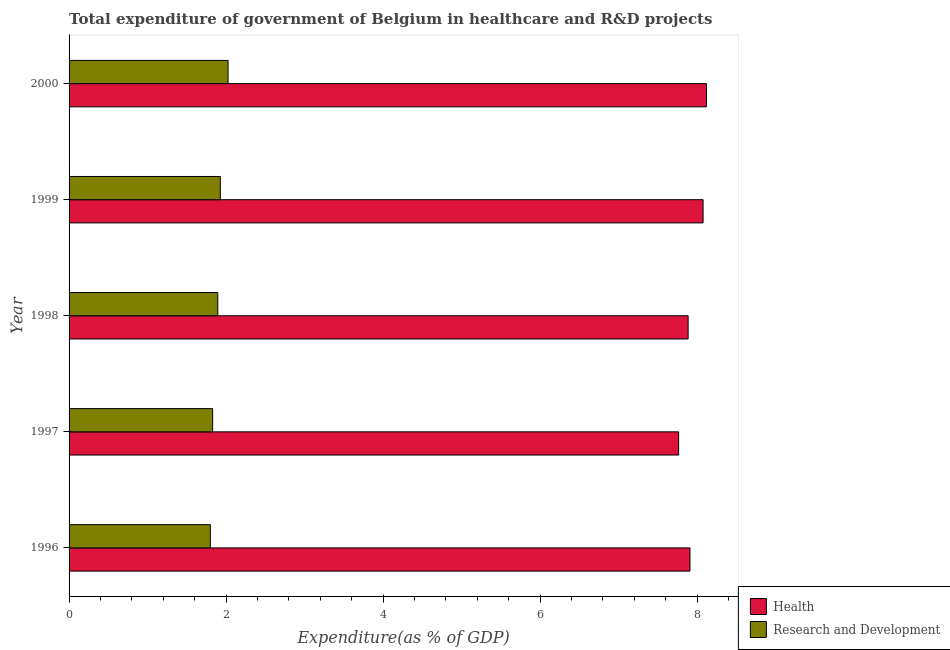How many groups of bars are there?
Provide a short and direct response. 5. Are the number of bars per tick equal to the number of legend labels?
Make the answer very short. Yes. How many bars are there on the 1st tick from the top?
Give a very brief answer. 2. How many bars are there on the 5th tick from the bottom?
Your answer should be compact. 2. In how many cases, is the number of bars for a given year not equal to the number of legend labels?
Ensure brevity in your answer.  0. What is the expenditure in r&d in 2000?
Provide a short and direct response. 2.03. Across all years, what is the maximum expenditure in healthcare?
Offer a terse response. 8.12. Across all years, what is the minimum expenditure in r&d?
Offer a terse response. 1.8. In which year was the expenditure in healthcare maximum?
Keep it short and to the point. 2000. What is the total expenditure in healthcare in the graph?
Your answer should be very brief. 39.76. What is the difference between the expenditure in healthcare in 1997 and that in 2000?
Provide a short and direct response. -0.35. What is the difference between the expenditure in healthcare in 2000 and the expenditure in r&d in 1997?
Provide a succinct answer. 6.29. What is the average expenditure in healthcare per year?
Make the answer very short. 7.95. In the year 1998, what is the difference between the expenditure in r&d and expenditure in healthcare?
Keep it short and to the point. -5.99. In how many years, is the expenditure in r&d greater than 4 %?
Ensure brevity in your answer.  0. What is the ratio of the expenditure in r&d in 1999 to that in 2000?
Provide a short and direct response. 0.95. Is the expenditure in healthcare in 1997 less than that in 2000?
Offer a very short reply. Yes. What is the difference between the highest and the second highest expenditure in r&d?
Offer a terse response. 0.1. What is the difference between the highest and the lowest expenditure in r&d?
Give a very brief answer. 0.23. In how many years, is the expenditure in healthcare greater than the average expenditure in healthcare taken over all years?
Provide a succinct answer. 2. Is the sum of the expenditure in healthcare in 1998 and 2000 greater than the maximum expenditure in r&d across all years?
Offer a terse response. Yes. What does the 2nd bar from the top in 1996 represents?
Your answer should be compact. Health. What does the 2nd bar from the bottom in 1998 represents?
Offer a very short reply. Research and Development. How many years are there in the graph?
Provide a short and direct response. 5. Are the values on the major ticks of X-axis written in scientific E-notation?
Offer a terse response. No. Does the graph contain any zero values?
Give a very brief answer. No. Where does the legend appear in the graph?
Provide a short and direct response. Bottom right. What is the title of the graph?
Provide a succinct answer. Total expenditure of government of Belgium in healthcare and R&D projects. Does "National Tourists" appear as one of the legend labels in the graph?
Your response must be concise. No. What is the label or title of the X-axis?
Your answer should be compact. Expenditure(as % of GDP). What is the label or title of the Y-axis?
Ensure brevity in your answer.  Year. What is the Expenditure(as % of GDP) of Health in 1996?
Offer a terse response. 7.91. What is the Expenditure(as % of GDP) in Research and Development in 1996?
Your response must be concise. 1.8. What is the Expenditure(as % of GDP) of Health in 1997?
Offer a very short reply. 7.77. What is the Expenditure(as % of GDP) of Research and Development in 1997?
Offer a very short reply. 1.83. What is the Expenditure(as % of GDP) in Health in 1998?
Offer a very short reply. 7.89. What is the Expenditure(as % of GDP) in Research and Development in 1998?
Offer a terse response. 1.89. What is the Expenditure(as % of GDP) in Health in 1999?
Offer a terse response. 8.08. What is the Expenditure(as % of GDP) of Research and Development in 1999?
Provide a succinct answer. 1.93. What is the Expenditure(as % of GDP) in Health in 2000?
Offer a terse response. 8.12. What is the Expenditure(as % of GDP) in Research and Development in 2000?
Your answer should be compact. 2.03. Across all years, what is the maximum Expenditure(as % of GDP) of Health?
Offer a very short reply. 8.12. Across all years, what is the maximum Expenditure(as % of GDP) in Research and Development?
Keep it short and to the point. 2.03. Across all years, what is the minimum Expenditure(as % of GDP) in Health?
Keep it short and to the point. 7.77. Across all years, what is the minimum Expenditure(as % of GDP) of Research and Development?
Your answer should be very brief. 1.8. What is the total Expenditure(as % of GDP) of Health in the graph?
Your answer should be compact. 39.76. What is the total Expenditure(as % of GDP) in Research and Development in the graph?
Provide a succinct answer. 9.48. What is the difference between the Expenditure(as % of GDP) of Health in 1996 and that in 1997?
Make the answer very short. 0.14. What is the difference between the Expenditure(as % of GDP) of Research and Development in 1996 and that in 1997?
Make the answer very short. -0.03. What is the difference between the Expenditure(as % of GDP) of Health in 1996 and that in 1998?
Offer a very short reply. 0.02. What is the difference between the Expenditure(as % of GDP) of Research and Development in 1996 and that in 1998?
Your answer should be compact. -0.09. What is the difference between the Expenditure(as % of GDP) in Research and Development in 1996 and that in 1999?
Give a very brief answer. -0.13. What is the difference between the Expenditure(as % of GDP) of Health in 1996 and that in 2000?
Your answer should be very brief. -0.21. What is the difference between the Expenditure(as % of GDP) in Research and Development in 1996 and that in 2000?
Offer a very short reply. -0.23. What is the difference between the Expenditure(as % of GDP) of Health in 1997 and that in 1998?
Make the answer very short. -0.12. What is the difference between the Expenditure(as % of GDP) in Research and Development in 1997 and that in 1998?
Offer a terse response. -0.07. What is the difference between the Expenditure(as % of GDP) of Health in 1997 and that in 1999?
Keep it short and to the point. -0.31. What is the difference between the Expenditure(as % of GDP) in Research and Development in 1997 and that in 1999?
Ensure brevity in your answer.  -0.1. What is the difference between the Expenditure(as % of GDP) in Health in 1997 and that in 2000?
Provide a succinct answer. -0.36. What is the difference between the Expenditure(as % of GDP) in Research and Development in 1997 and that in 2000?
Offer a very short reply. -0.2. What is the difference between the Expenditure(as % of GDP) in Health in 1998 and that in 1999?
Provide a short and direct response. -0.19. What is the difference between the Expenditure(as % of GDP) of Research and Development in 1998 and that in 1999?
Give a very brief answer. -0.03. What is the difference between the Expenditure(as % of GDP) in Health in 1998 and that in 2000?
Make the answer very short. -0.23. What is the difference between the Expenditure(as % of GDP) in Research and Development in 1998 and that in 2000?
Keep it short and to the point. -0.13. What is the difference between the Expenditure(as % of GDP) in Health in 1999 and that in 2000?
Provide a succinct answer. -0.04. What is the difference between the Expenditure(as % of GDP) of Research and Development in 1999 and that in 2000?
Your answer should be compact. -0.1. What is the difference between the Expenditure(as % of GDP) in Health in 1996 and the Expenditure(as % of GDP) in Research and Development in 1997?
Your answer should be very brief. 6.08. What is the difference between the Expenditure(as % of GDP) in Health in 1996 and the Expenditure(as % of GDP) in Research and Development in 1998?
Offer a terse response. 6.02. What is the difference between the Expenditure(as % of GDP) of Health in 1996 and the Expenditure(as % of GDP) of Research and Development in 1999?
Your answer should be very brief. 5.98. What is the difference between the Expenditure(as % of GDP) in Health in 1996 and the Expenditure(as % of GDP) in Research and Development in 2000?
Offer a terse response. 5.88. What is the difference between the Expenditure(as % of GDP) in Health in 1997 and the Expenditure(as % of GDP) in Research and Development in 1998?
Give a very brief answer. 5.87. What is the difference between the Expenditure(as % of GDP) of Health in 1997 and the Expenditure(as % of GDP) of Research and Development in 1999?
Ensure brevity in your answer.  5.84. What is the difference between the Expenditure(as % of GDP) in Health in 1997 and the Expenditure(as % of GDP) in Research and Development in 2000?
Offer a terse response. 5.74. What is the difference between the Expenditure(as % of GDP) of Health in 1998 and the Expenditure(as % of GDP) of Research and Development in 1999?
Provide a short and direct response. 5.96. What is the difference between the Expenditure(as % of GDP) in Health in 1998 and the Expenditure(as % of GDP) in Research and Development in 2000?
Offer a terse response. 5.86. What is the difference between the Expenditure(as % of GDP) of Health in 1999 and the Expenditure(as % of GDP) of Research and Development in 2000?
Provide a short and direct response. 6.05. What is the average Expenditure(as % of GDP) of Health per year?
Give a very brief answer. 7.95. What is the average Expenditure(as % of GDP) in Research and Development per year?
Keep it short and to the point. 1.9. In the year 1996, what is the difference between the Expenditure(as % of GDP) in Health and Expenditure(as % of GDP) in Research and Development?
Make the answer very short. 6.11. In the year 1997, what is the difference between the Expenditure(as % of GDP) in Health and Expenditure(as % of GDP) in Research and Development?
Provide a succinct answer. 5.94. In the year 1998, what is the difference between the Expenditure(as % of GDP) of Health and Expenditure(as % of GDP) of Research and Development?
Make the answer very short. 5.99. In the year 1999, what is the difference between the Expenditure(as % of GDP) of Health and Expenditure(as % of GDP) of Research and Development?
Provide a succinct answer. 6.15. In the year 2000, what is the difference between the Expenditure(as % of GDP) in Health and Expenditure(as % of GDP) in Research and Development?
Give a very brief answer. 6.1. What is the ratio of the Expenditure(as % of GDP) in Health in 1996 to that in 1997?
Ensure brevity in your answer.  1.02. What is the ratio of the Expenditure(as % of GDP) in Health in 1996 to that in 1998?
Keep it short and to the point. 1. What is the ratio of the Expenditure(as % of GDP) in Health in 1996 to that in 1999?
Keep it short and to the point. 0.98. What is the ratio of the Expenditure(as % of GDP) of Research and Development in 1996 to that in 1999?
Ensure brevity in your answer.  0.93. What is the ratio of the Expenditure(as % of GDP) of Health in 1996 to that in 2000?
Provide a short and direct response. 0.97. What is the ratio of the Expenditure(as % of GDP) of Research and Development in 1996 to that in 2000?
Your response must be concise. 0.89. What is the ratio of the Expenditure(as % of GDP) in Health in 1997 to that in 1998?
Offer a terse response. 0.98. What is the ratio of the Expenditure(as % of GDP) in Research and Development in 1997 to that in 1998?
Your answer should be compact. 0.97. What is the ratio of the Expenditure(as % of GDP) of Health in 1997 to that in 1999?
Keep it short and to the point. 0.96. What is the ratio of the Expenditure(as % of GDP) of Research and Development in 1997 to that in 1999?
Your response must be concise. 0.95. What is the ratio of the Expenditure(as % of GDP) of Health in 1997 to that in 2000?
Provide a short and direct response. 0.96. What is the ratio of the Expenditure(as % of GDP) of Research and Development in 1997 to that in 2000?
Provide a succinct answer. 0.9. What is the ratio of the Expenditure(as % of GDP) in Health in 1998 to that in 1999?
Offer a very short reply. 0.98. What is the ratio of the Expenditure(as % of GDP) in Research and Development in 1998 to that in 1999?
Keep it short and to the point. 0.98. What is the ratio of the Expenditure(as % of GDP) in Health in 1998 to that in 2000?
Your answer should be compact. 0.97. What is the ratio of the Expenditure(as % of GDP) of Research and Development in 1998 to that in 2000?
Give a very brief answer. 0.94. What is the ratio of the Expenditure(as % of GDP) in Health in 1999 to that in 2000?
Your response must be concise. 0.99. What is the ratio of the Expenditure(as % of GDP) in Research and Development in 1999 to that in 2000?
Offer a terse response. 0.95. What is the difference between the highest and the second highest Expenditure(as % of GDP) of Health?
Make the answer very short. 0.04. What is the difference between the highest and the second highest Expenditure(as % of GDP) in Research and Development?
Provide a short and direct response. 0.1. What is the difference between the highest and the lowest Expenditure(as % of GDP) in Health?
Give a very brief answer. 0.36. What is the difference between the highest and the lowest Expenditure(as % of GDP) in Research and Development?
Your answer should be compact. 0.23. 